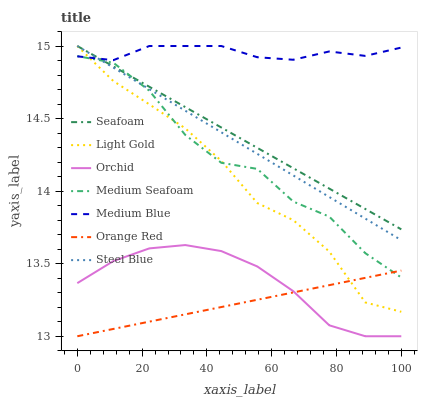Does Orange Red have the minimum area under the curve?
Answer yes or no. Yes. Does Medium Blue have the maximum area under the curve?
Answer yes or no. Yes. Does Seafoam have the minimum area under the curve?
Answer yes or no. No. Does Seafoam have the maximum area under the curve?
Answer yes or no. No. Is Seafoam the smoothest?
Answer yes or no. Yes. Is Medium Seafoam the roughest?
Answer yes or no. Yes. Is Orange Red the smoothest?
Answer yes or no. No. Is Orange Red the roughest?
Answer yes or no. No. Does Orange Red have the lowest value?
Answer yes or no. Yes. Does Seafoam have the lowest value?
Answer yes or no. No. Does Light Gold have the highest value?
Answer yes or no. Yes. Does Orange Red have the highest value?
Answer yes or no. No. Is Orchid less than Medium Seafoam?
Answer yes or no. Yes. Is Seafoam greater than Orchid?
Answer yes or no. Yes. Does Light Gold intersect Seafoam?
Answer yes or no. Yes. Is Light Gold less than Seafoam?
Answer yes or no. No. Is Light Gold greater than Seafoam?
Answer yes or no. No. Does Orchid intersect Medium Seafoam?
Answer yes or no. No. 